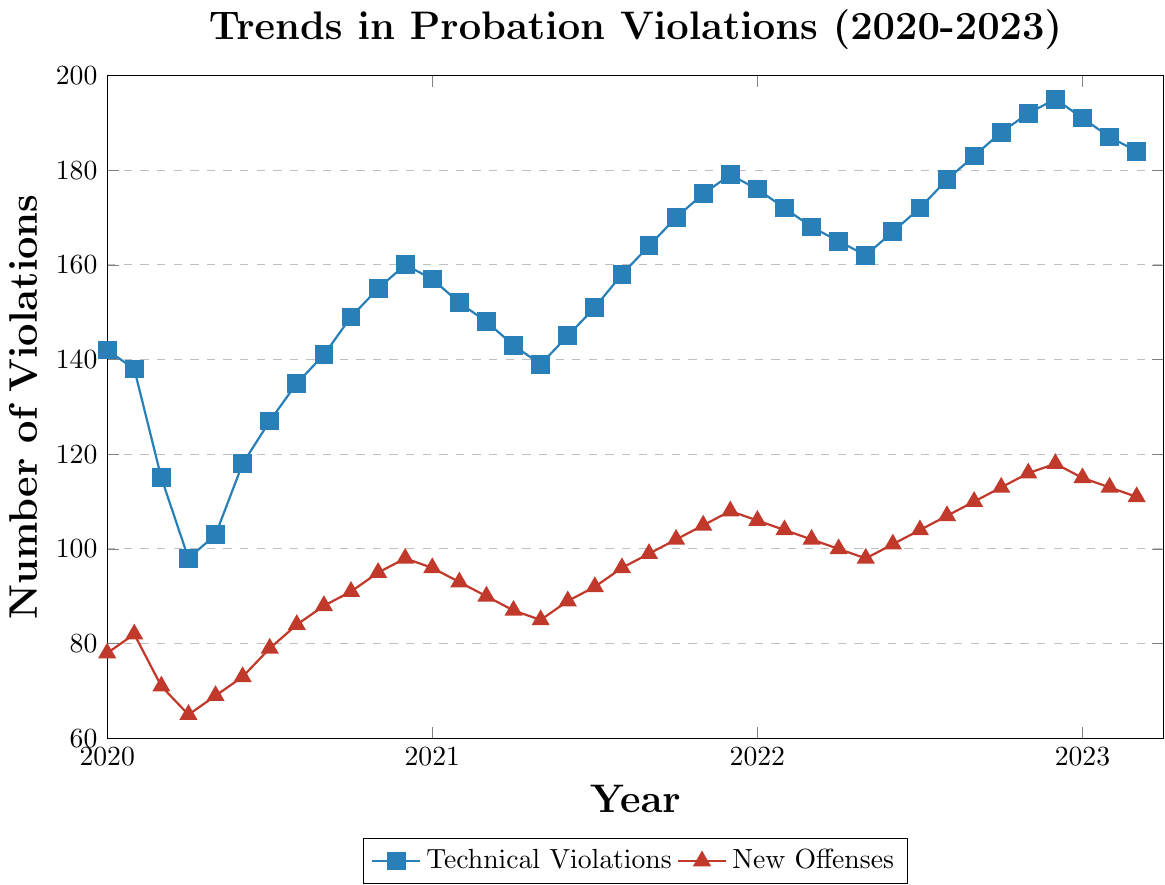What is the trend of technical violations from January 2020 to March 2023? The trend of technical violations increases steadily over the three-year period. Starting from 142 in January 2020, it shows a generally upward trend with some fluctuations, reaching 184 in March 2023.
Answer: Upward What was the highest number of new offenses recorded in a single month during the period covered? The highest number of new offenses recorded is 118 in December 2022. This can be observed at the end of the year 2022 on the red line representing new offenses.
Answer: 118 How did the number of technical violations change from January 2021 to December 2021? In January 2021, technical violations were at 157 and by December 2021 they increased to 179. This represents an upward trend throughout 2021.
Answer: Increased Which type of violation had a more noticeable increase over the last three years, technical violations or new offenses? Comparing the starting point in January 2020 to the ending point in March 2023, technical violations increased from 142 to 184, whereas new offenses increased from 78 to 111. Both saw a noticeable increase, but technical violations had a sharper rise.
Answer: Technical violations Compare the number of technical violations and new offenses in December 2020. Which was higher and by how much? In December 2020, technical violations were 160 and new offenses were 98. Technical violations were higher by 62.
Answer: Technical violations by 62 During which month in 2021 did both types of violations experience the smallest gap, and what was the gap? The smallest gap between technical violations and new offenses in 2021 occurred in May. Technical violations were 139 and new offenses were 85, making the gap 54.
Answer: May, gap of 54 What is the average number of technical violations per month for the year 2022? Sum the number of technical violations for each month in 2022 and divide by 12. The sum is \(176 + 172 + 168 + 165 + 162 + 167 + 172 + 178 + 183 + 188 + 192 + 195 = 2118\). The average is \(2118 / 12 \approx 176.5\).
Answer: 176.5 What was the trend of new offenses in the first quarter of 2020? From January to March 2020, new offenses show a decreasing trend. They start at 78 in January and decrease to 71 by March.
Answer: Decreasing In which month did both technical violations and new offenses peak, and what were the values? Both peaked in December 2022. Technical violations peaked at 195 and new offenses at 118.
Answer: December 2022, 195 and 118 